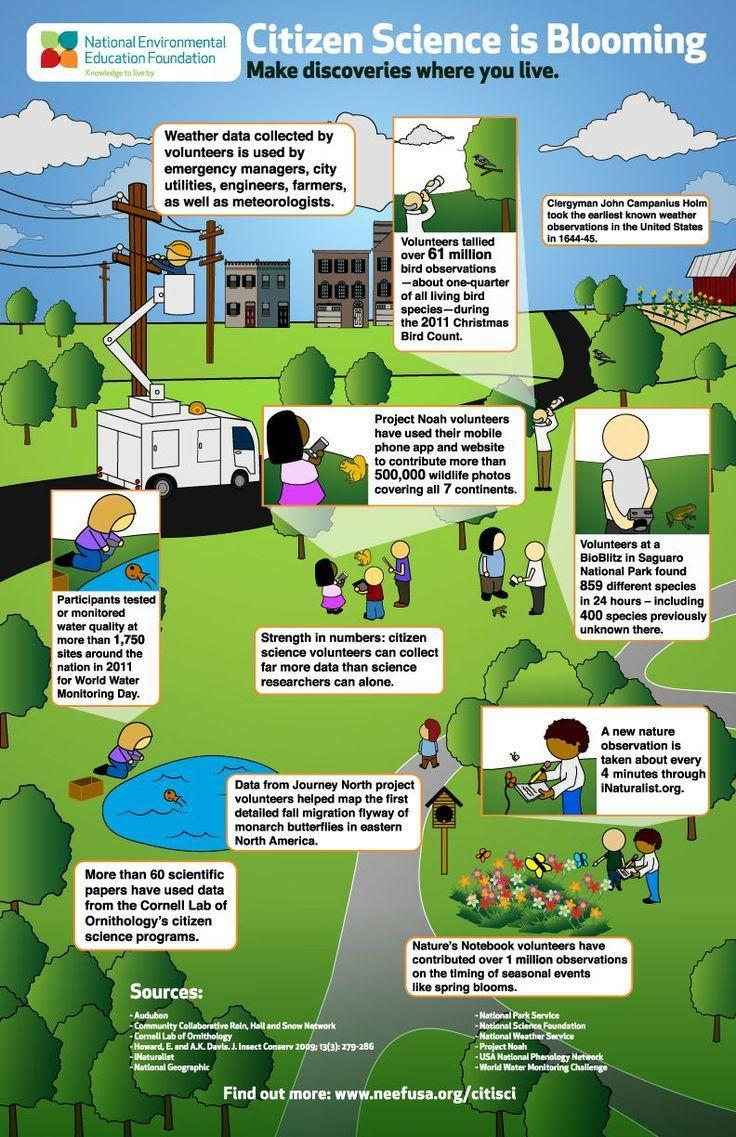How many buildings are in this infographic?
Answer the question with a short phrase. 4 How many fish are in this infographic? 2 